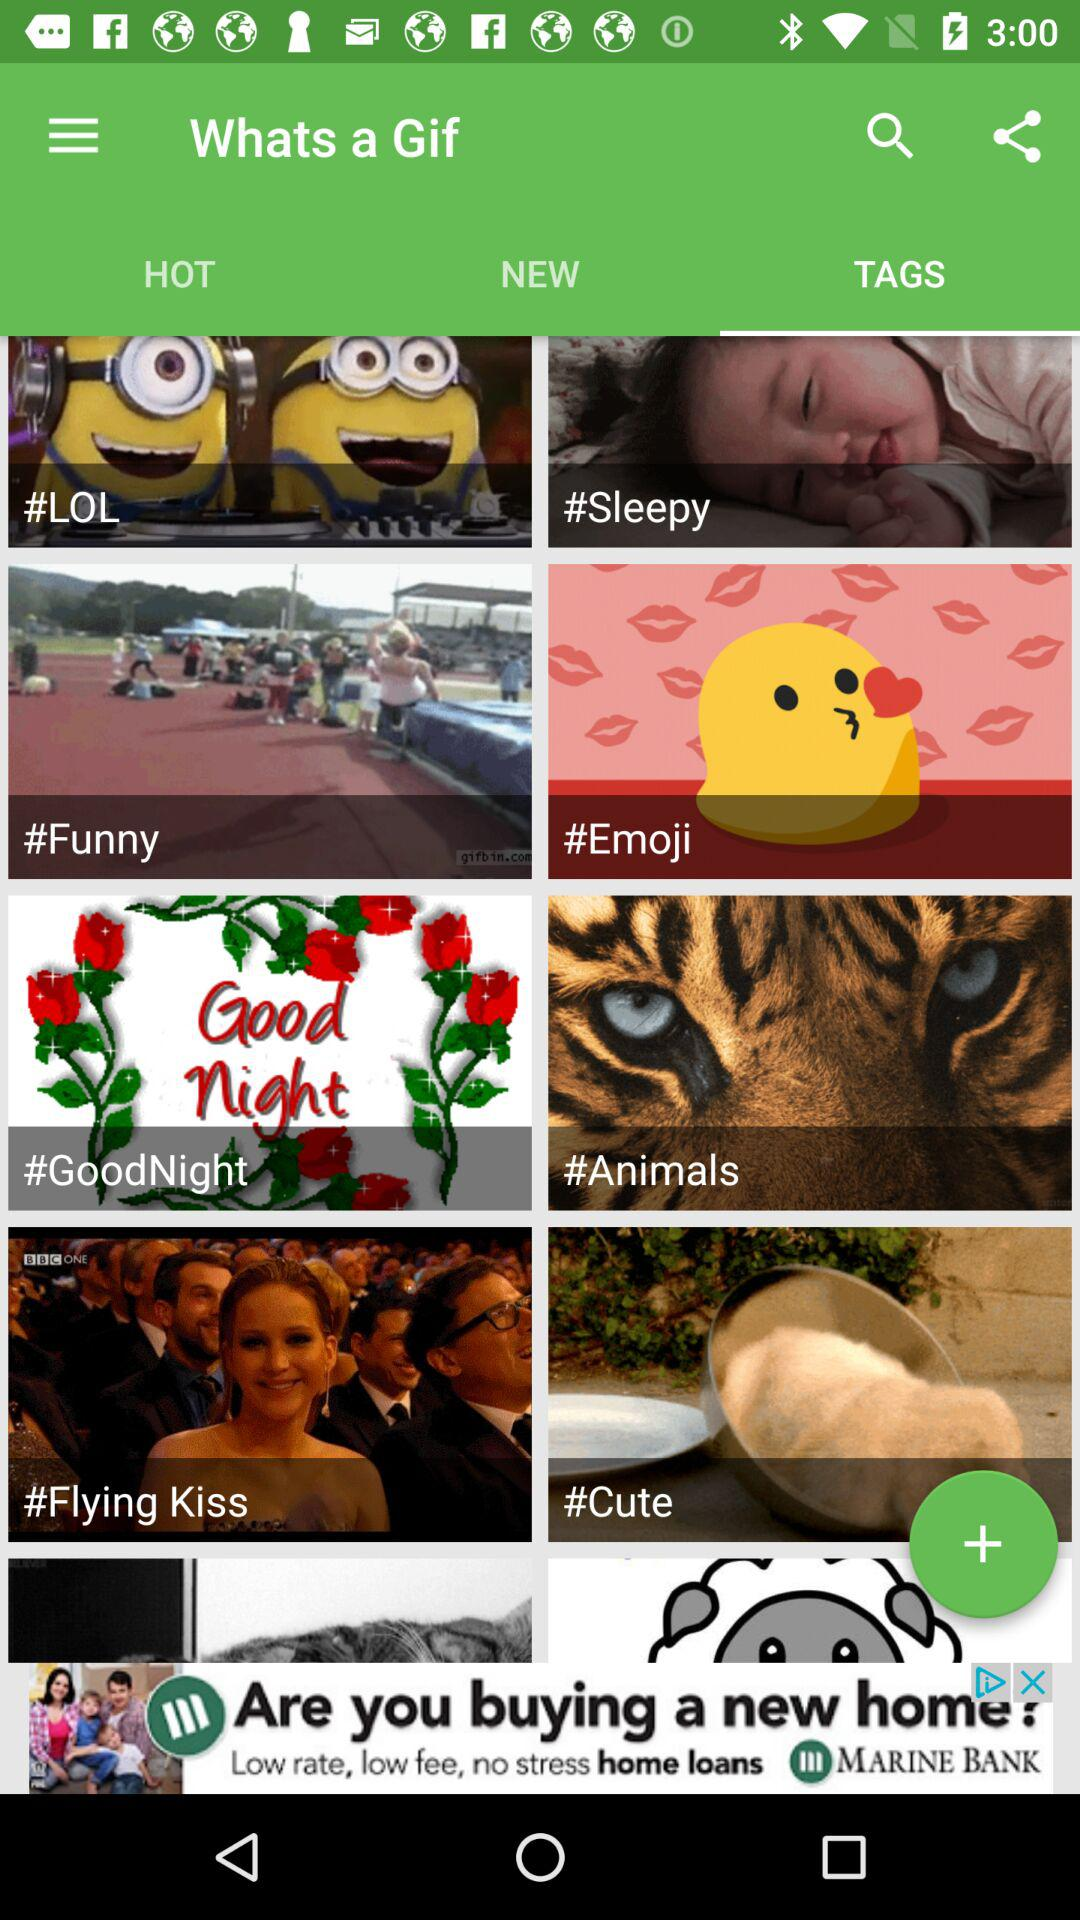Which tab is selected? The selected tab is "TAGS". 